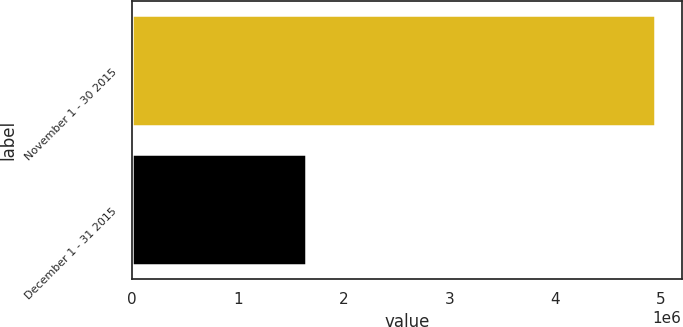<chart> <loc_0><loc_0><loc_500><loc_500><bar_chart><fcel>November 1 - 30 2015<fcel>December 1 - 31 2015<nl><fcel>4.94839e+06<fcel>1.64719e+06<nl></chart> 